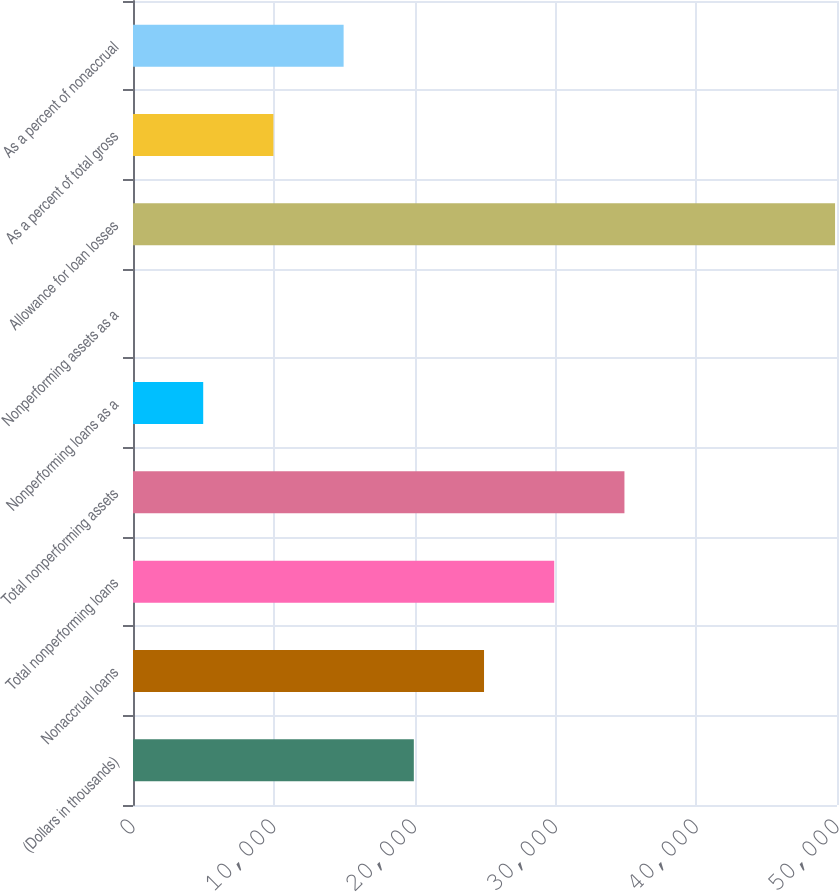<chart> <loc_0><loc_0><loc_500><loc_500><bar_chart><fcel>(Dollars in thousands)<fcel>Nonaccrual loans<fcel>Total nonperforming loans<fcel>Total nonperforming assets<fcel>Nonperforming loans as a<fcel>Nonperforming assets as a<fcel>Allowance for loan losses<fcel>As a percent of total gross<fcel>As a percent of nonaccrual<nl><fcel>19945<fcel>24931.1<fcel>29917.3<fcel>34903.5<fcel>4986.45<fcel>0.28<fcel>49862<fcel>9972.62<fcel>14958.8<nl></chart> 